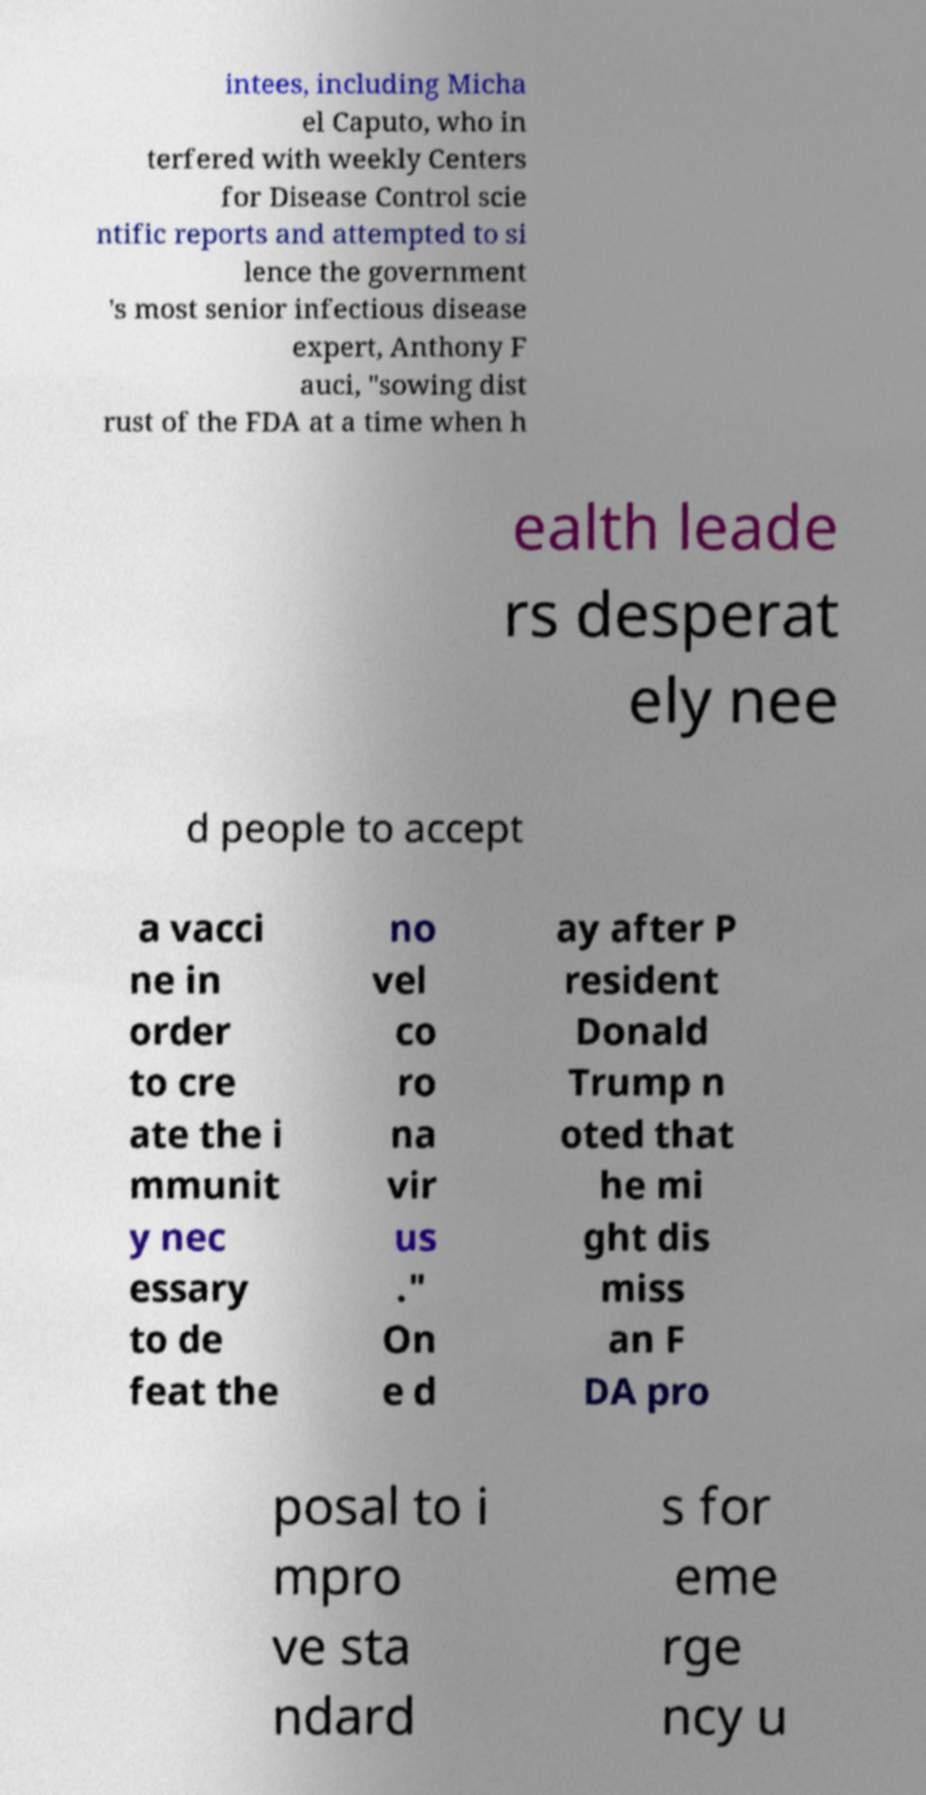I need the written content from this picture converted into text. Can you do that? intees, including Micha el Caputo, who in terfered with weekly Centers for Disease Control scie ntific reports and attempted to si lence the government 's most senior infectious disease expert, Anthony F auci, "sowing dist rust of the FDA at a time when h ealth leade rs desperat ely nee d people to accept a vacci ne in order to cre ate the i mmunit y nec essary to de feat the no vel co ro na vir us ." On e d ay after P resident Donald Trump n oted that he mi ght dis miss an F DA pro posal to i mpro ve sta ndard s for eme rge ncy u 